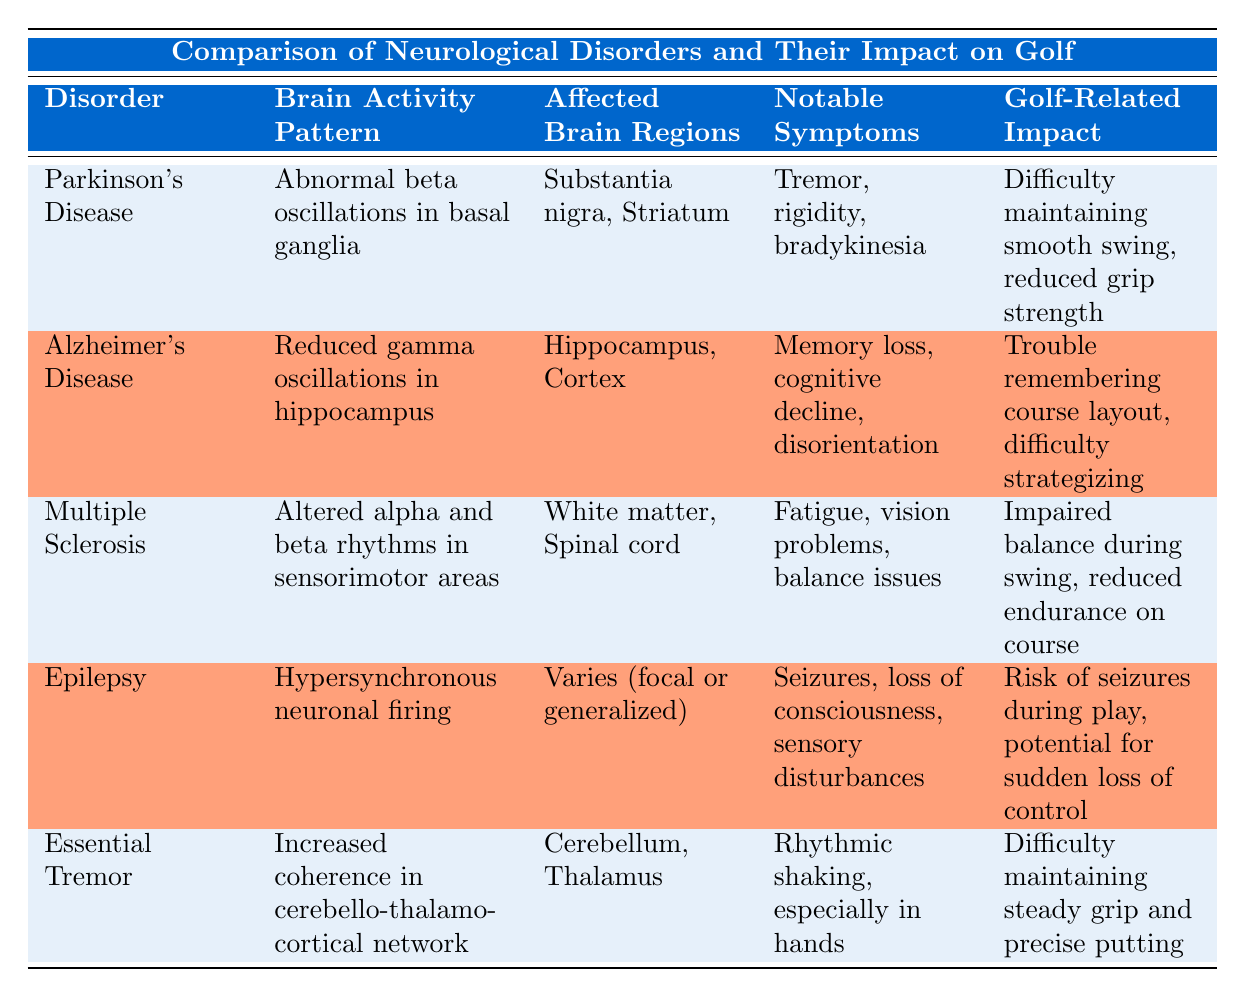What brain activity pattern is associated with Alzheimer's Disease? From the table, we can directly see that the brain activity pattern associated with Alzheimer's Disease is "Reduced gamma oscillations in hippocampus."
Answer: Reduced gamma oscillations in hippocampus Which neurological disorder affects the Substantia nigra and Striatum? By looking at the affected brain regions, we find that Parkinson's Disease is the disorder that affects the Substantia nigra and Striatum.
Answer: Parkinson's Disease Do both Parkinson's Disease and Essential Tremor share any common notable symptoms? Checking the notable symptoms, Parkinson's Disease has symptoms of "tremor, rigidity, bradykinesia," while Essential Tremor has "rhythmic shaking, especially in hands." Although both have tremors, the additional symptoms are different. Therefore, they do not completely share common notable symptoms.
Answer: No What is the notable symptom of Multiple Sclerosis related to balance? The notable symptom related to balance for Multiple Sclerosis is "balance issues," as indicated in the table.
Answer: Balance issues Compare the golf-related impacts of Alzheimer's Disease and Multiple Sclerosis. Alzheimer's Disease's golf-related impact is "Trouble remembering course layout, difficulty strategizing," while Multiple Sclerosis has "Impaired balance during swing, reduced endurance on course." Both disorders affect golf performance but in different aspects; Alzheimer's affects cognitive aspects while Multiple Sclerosis affects physical capabilities.
Answer: Alzheimer's impacts cognition; Multiple Sclerosis impacts physical capabilities 